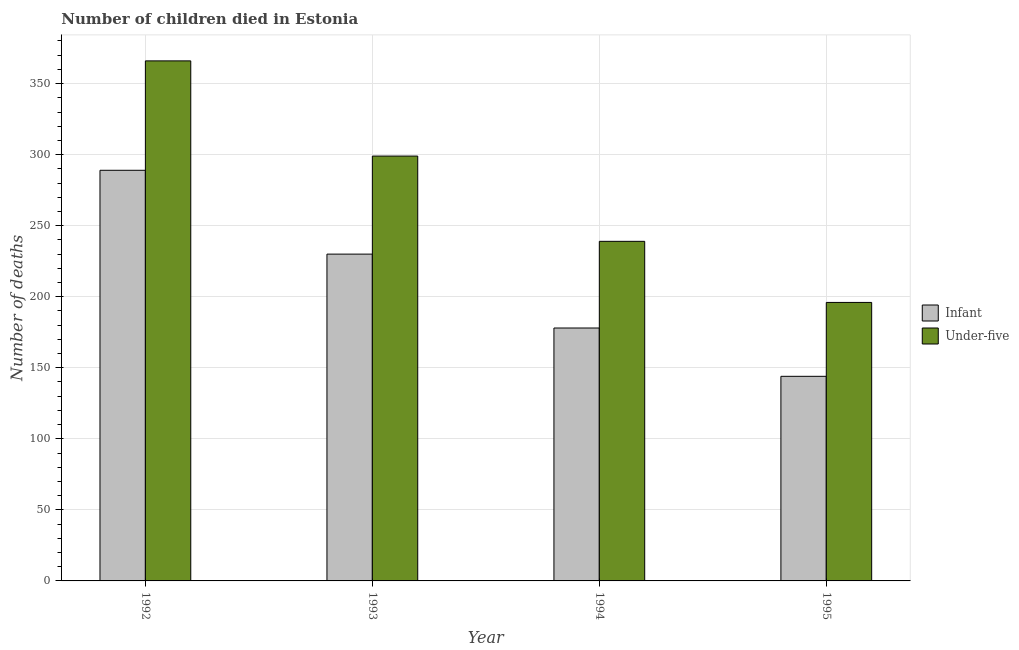How many different coloured bars are there?
Keep it short and to the point. 2. How many groups of bars are there?
Provide a short and direct response. 4. Are the number of bars per tick equal to the number of legend labels?
Keep it short and to the point. Yes. In how many cases, is the number of bars for a given year not equal to the number of legend labels?
Offer a very short reply. 0. What is the number of infant deaths in 1994?
Your answer should be compact. 178. Across all years, what is the maximum number of infant deaths?
Your answer should be compact. 289. Across all years, what is the minimum number of under-five deaths?
Provide a short and direct response. 196. What is the total number of under-five deaths in the graph?
Your answer should be compact. 1100. What is the difference between the number of under-five deaths in 1992 and that in 1995?
Your answer should be very brief. 170. What is the difference between the number of under-five deaths in 1994 and the number of infant deaths in 1993?
Provide a short and direct response. -60. What is the average number of under-five deaths per year?
Offer a very short reply. 275. In the year 1993, what is the difference between the number of infant deaths and number of under-five deaths?
Your response must be concise. 0. What is the ratio of the number of under-five deaths in 1992 to that in 1993?
Ensure brevity in your answer.  1.22. Is the difference between the number of under-five deaths in 1994 and 1995 greater than the difference between the number of infant deaths in 1994 and 1995?
Ensure brevity in your answer.  No. What is the difference between the highest and the lowest number of infant deaths?
Provide a short and direct response. 145. In how many years, is the number of under-five deaths greater than the average number of under-five deaths taken over all years?
Ensure brevity in your answer.  2. What does the 1st bar from the left in 1992 represents?
Make the answer very short. Infant. What does the 2nd bar from the right in 1995 represents?
Keep it short and to the point. Infant. How many bars are there?
Offer a very short reply. 8. Are all the bars in the graph horizontal?
Provide a short and direct response. No. What is the difference between two consecutive major ticks on the Y-axis?
Keep it short and to the point. 50. Does the graph contain any zero values?
Give a very brief answer. No. Does the graph contain grids?
Your answer should be compact. Yes. Where does the legend appear in the graph?
Ensure brevity in your answer.  Center right. How are the legend labels stacked?
Your response must be concise. Vertical. What is the title of the graph?
Provide a succinct answer. Number of children died in Estonia. What is the label or title of the Y-axis?
Your response must be concise. Number of deaths. What is the Number of deaths in Infant in 1992?
Keep it short and to the point. 289. What is the Number of deaths in Under-five in 1992?
Your response must be concise. 366. What is the Number of deaths of Infant in 1993?
Your answer should be compact. 230. What is the Number of deaths of Under-five in 1993?
Your answer should be very brief. 299. What is the Number of deaths in Infant in 1994?
Your answer should be very brief. 178. What is the Number of deaths of Under-five in 1994?
Offer a very short reply. 239. What is the Number of deaths of Infant in 1995?
Provide a succinct answer. 144. What is the Number of deaths of Under-five in 1995?
Your response must be concise. 196. Across all years, what is the maximum Number of deaths in Infant?
Keep it short and to the point. 289. Across all years, what is the maximum Number of deaths of Under-five?
Keep it short and to the point. 366. Across all years, what is the minimum Number of deaths in Infant?
Your answer should be very brief. 144. Across all years, what is the minimum Number of deaths of Under-five?
Your answer should be compact. 196. What is the total Number of deaths in Infant in the graph?
Make the answer very short. 841. What is the total Number of deaths of Under-five in the graph?
Your answer should be compact. 1100. What is the difference between the Number of deaths in Infant in 1992 and that in 1993?
Provide a short and direct response. 59. What is the difference between the Number of deaths of Infant in 1992 and that in 1994?
Ensure brevity in your answer.  111. What is the difference between the Number of deaths in Under-five in 1992 and that in 1994?
Provide a succinct answer. 127. What is the difference between the Number of deaths of Infant in 1992 and that in 1995?
Your answer should be very brief. 145. What is the difference between the Number of deaths in Under-five in 1992 and that in 1995?
Provide a short and direct response. 170. What is the difference between the Number of deaths in Under-five in 1993 and that in 1995?
Your answer should be compact. 103. What is the difference between the Number of deaths of Infant in 1994 and that in 1995?
Offer a very short reply. 34. What is the difference between the Number of deaths in Under-five in 1994 and that in 1995?
Keep it short and to the point. 43. What is the difference between the Number of deaths of Infant in 1992 and the Number of deaths of Under-five in 1995?
Offer a very short reply. 93. What is the difference between the Number of deaths in Infant in 1993 and the Number of deaths in Under-five in 1995?
Your answer should be very brief. 34. What is the average Number of deaths in Infant per year?
Your answer should be very brief. 210.25. What is the average Number of deaths of Under-five per year?
Provide a succinct answer. 275. In the year 1992, what is the difference between the Number of deaths in Infant and Number of deaths in Under-five?
Keep it short and to the point. -77. In the year 1993, what is the difference between the Number of deaths in Infant and Number of deaths in Under-five?
Your answer should be compact. -69. In the year 1994, what is the difference between the Number of deaths of Infant and Number of deaths of Under-five?
Your answer should be compact. -61. In the year 1995, what is the difference between the Number of deaths of Infant and Number of deaths of Under-five?
Ensure brevity in your answer.  -52. What is the ratio of the Number of deaths of Infant in 1992 to that in 1993?
Give a very brief answer. 1.26. What is the ratio of the Number of deaths in Under-five in 1992 to that in 1993?
Your answer should be compact. 1.22. What is the ratio of the Number of deaths in Infant in 1992 to that in 1994?
Offer a terse response. 1.62. What is the ratio of the Number of deaths in Under-five in 1992 to that in 1994?
Give a very brief answer. 1.53. What is the ratio of the Number of deaths of Infant in 1992 to that in 1995?
Offer a terse response. 2.01. What is the ratio of the Number of deaths of Under-five in 1992 to that in 1995?
Your answer should be very brief. 1.87. What is the ratio of the Number of deaths in Infant in 1993 to that in 1994?
Give a very brief answer. 1.29. What is the ratio of the Number of deaths in Under-five in 1993 to that in 1994?
Keep it short and to the point. 1.25. What is the ratio of the Number of deaths in Infant in 1993 to that in 1995?
Ensure brevity in your answer.  1.6. What is the ratio of the Number of deaths of Under-five in 1993 to that in 1995?
Ensure brevity in your answer.  1.53. What is the ratio of the Number of deaths in Infant in 1994 to that in 1995?
Ensure brevity in your answer.  1.24. What is the ratio of the Number of deaths in Under-five in 1994 to that in 1995?
Give a very brief answer. 1.22. What is the difference between the highest and the lowest Number of deaths of Infant?
Keep it short and to the point. 145. What is the difference between the highest and the lowest Number of deaths of Under-five?
Your response must be concise. 170. 